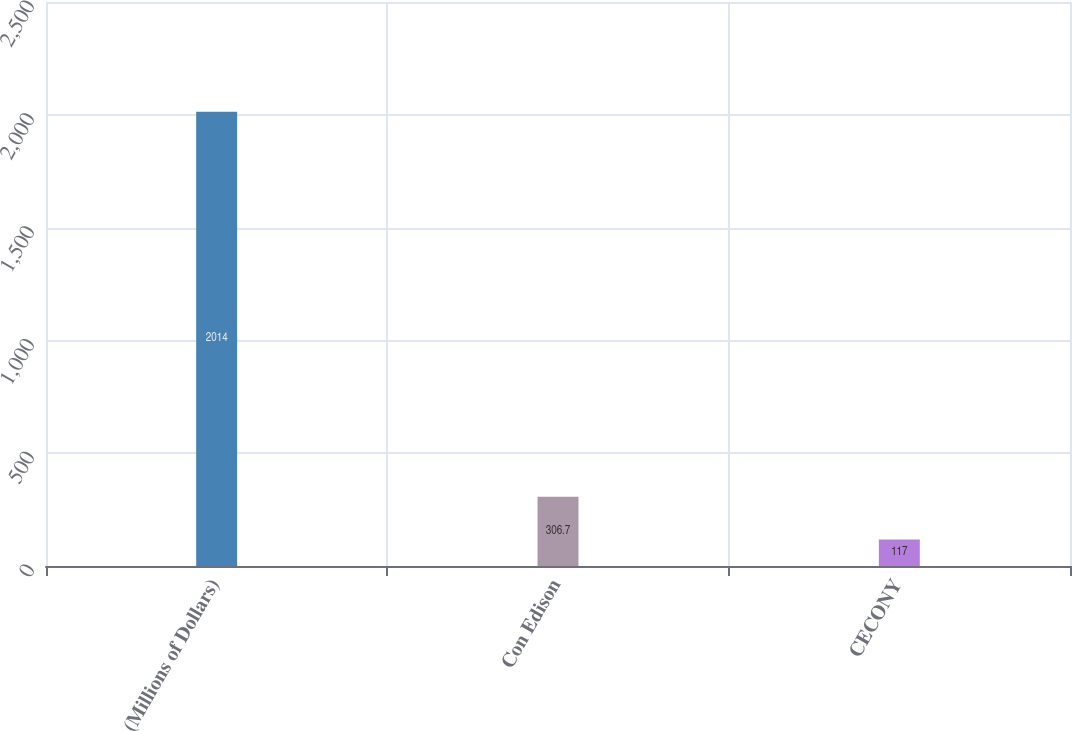Convert chart. <chart><loc_0><loc_0><loc_500><loc_500><bar_chart><fcel>(Millions of Dollars)<fcel>Con Edison<fcel>CECONY<nl><fcel>2014<fcel>306.7<fcel>117<nl></chart> 